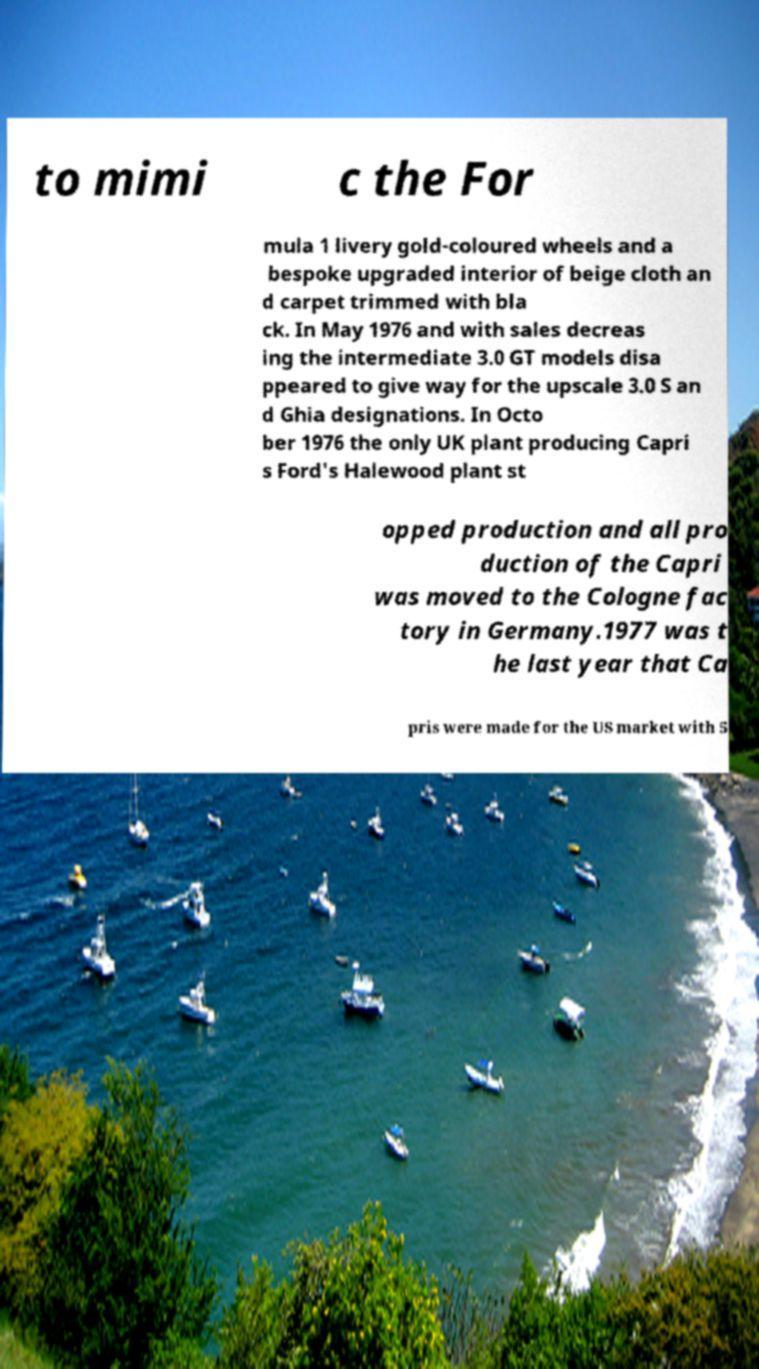There's text embedded in this image that I need extracted. Can you transcribe it verbatim? to mimi c the For mula 1 livery gold-coloured wheels and a bespoke upgraded interior of beige cloth an d carpet trimmed with bla ck. In May 1976 and with sales decreas ing the intermediate 3.0 GT models disa ppeared to give way for the upscale 3.0 S an d Ghia designations. In Octo ber 1976 the only UK plant producing Capri s Ford's Halewood plant st opped production and all pro duction of the Capri was moved to the Cologne fac tory in Germany.1977 was t he last year that Ca pris were made for the US market with 5 